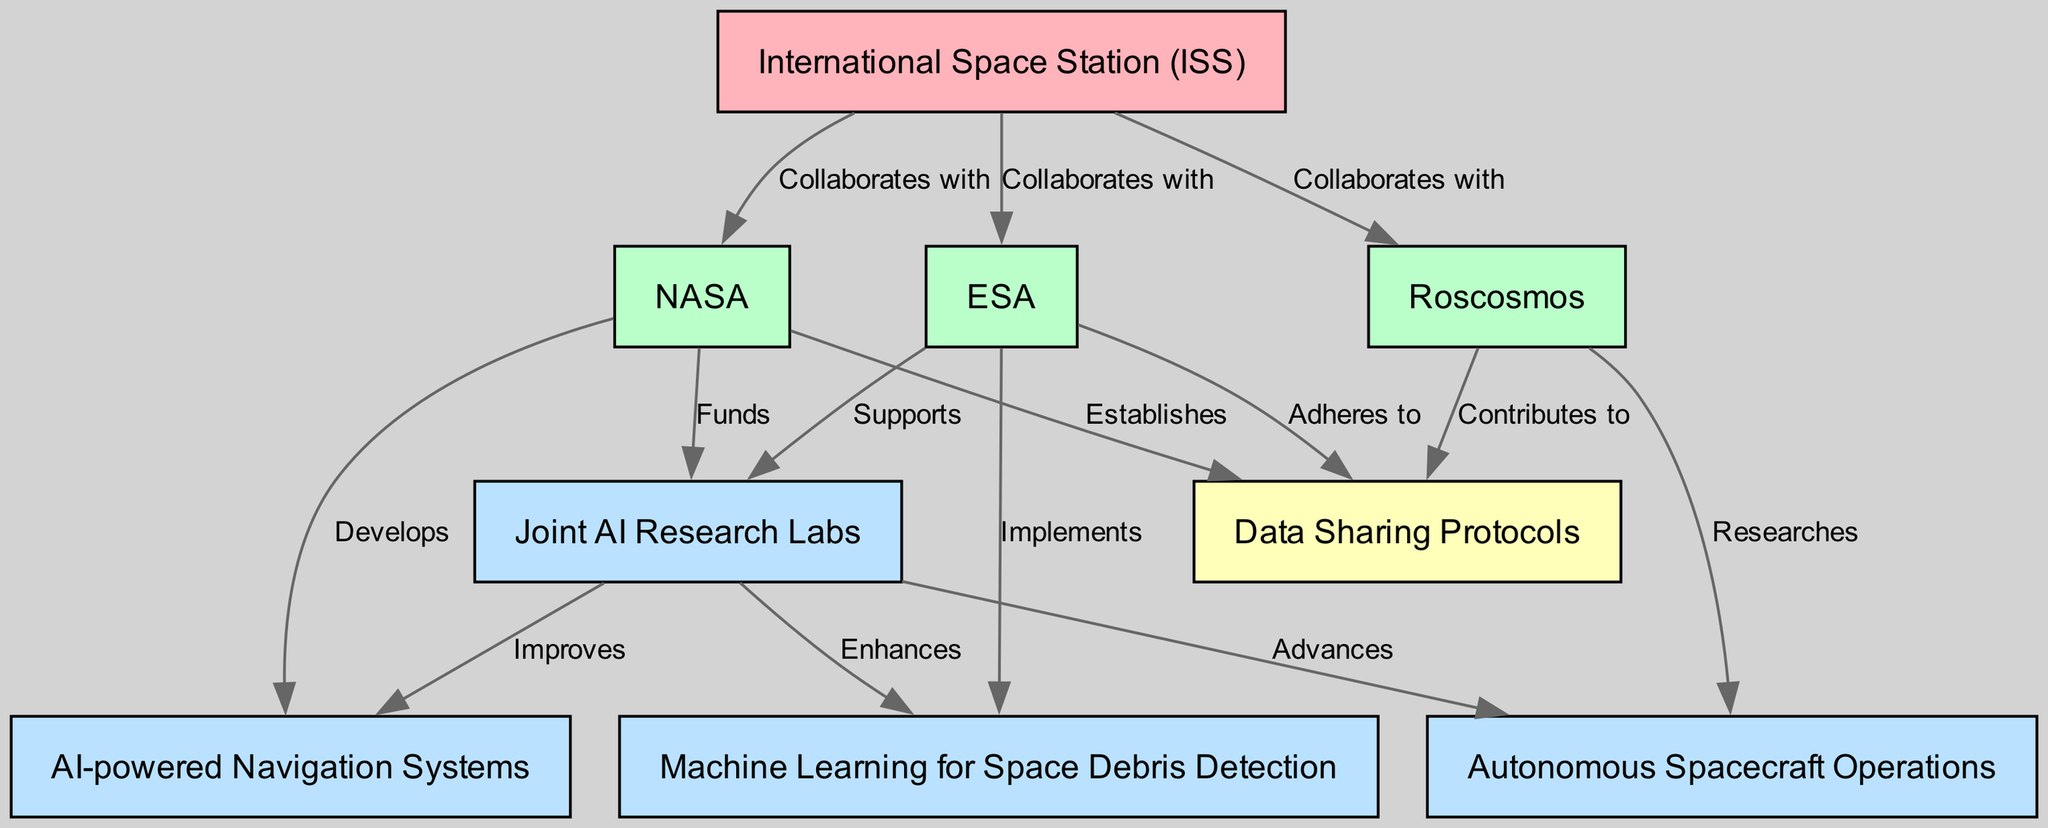What is the total number of nodes in the diagram? To find the total number of nodes, count the nodes listed in the diagram. There are 9 nodes present, such as the International Space Station, NASA, ESA, etc.
Answer: 9 Which agency collaborates with the International Space Station? The diagram shows three agencies collaborating with the ISS: NASA, ESA, and Roscosmos. Each has a direct connection from the ISS node to their respective nodes.
Answer: NASA, ESA, Roscosmos What does NASA develop according to the diagram? The edge from NASA to AI-powered Navigation Systems indicates that NASA is responsible for developing this technology. Looking at the label on that edge confirms this relationship.
Answer: AI-powered Navigation Systems Which agency supports the Joint AI Research Labs? The diagram indicates that both NASA and ESA are linked to the Joint AI Research Labs. NASA funds it while ESA supports it, but the question specifically asks for the agency that supports it, which is ESA.
Answer: ESA What relationship exists between the Joint AI Research Labs and AI-powered Navigation Systems? The Joint AI Research Labs improve AI-powered Navigation Systems, as indicated by the labeled edge from the research lab node to the navigation systems node.
Answer: Improves Which agency implements Machine Learning for Space Debris Detection? The diagram shows that ESA is responsible for implementing Machine Learning for Space Debris Detection, as there is a direct connection from the ESA node to that specific project node.
Answer: ESA How many edges are directed from the Joint AI Research Labs? The Joint AI Research Labs have three directed edges going out towards AI-powered Navigation Systems, Machine Learning for Space Debris Detection, and Autonomous Spacecraft Operations, indicating multiple outputs.
Answer: 3 What shared function do NASA, ESA, and Roscosmos have regarding Data Sharing Protocols? All three agencies have connections to the Data Sharing Protocols node indicating their involvement with data sharing for AI projects. NASA establishes protocols, ESA adheres to them, and Roscosmos contributes.
Answer: Collaborates Which agency is researching Autonomous Spacecraft Operations? The diagram clearly states that Roscosmos is the agency that researches Autonomous Spacecraft Operations, as indicated by the labeled edge connecting these two nodes.
Answer: Roscosmos 